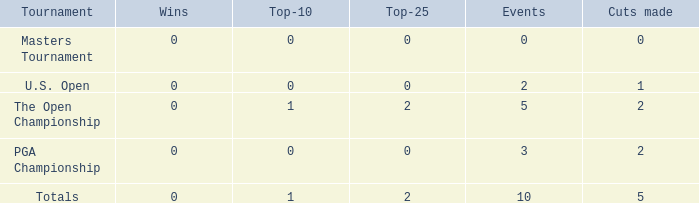What is the total number of top-10 finishes for events with at least one win? None. 